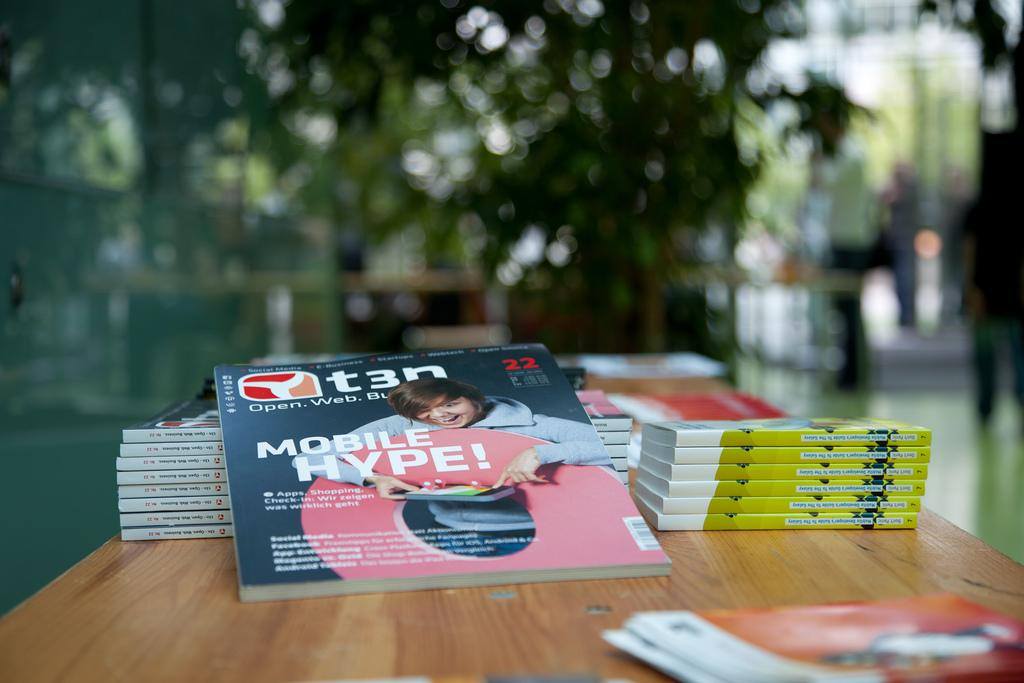<image>
Create a compact narrative representing the image presented. Magazines on a desk with the label T3N Mobile Hype! 